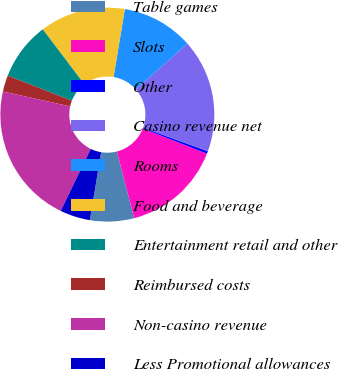<chart> <loc_0><loc_0><loc_500><loc_500><pie_chart><fcel>Table games<fcel>Slots<fcel>Other<fcel>Casino revenue net<fcel>Rooms<fcel>Food and beverage<fcel>Entertainment retail and other<fcel>Reimbursed costs<fcel>Non-casino revenue<fcel>Less Promotional allowances<nl><fcel>6.65%<fcel>15.02%<fcel>0.38%<fcel>17.11%<fcel>10.84%<fcel>12.93%<fcel>8.75%<fcel>2.47%<fcel>21.29%<fcel>4.56%<nl></chart> 